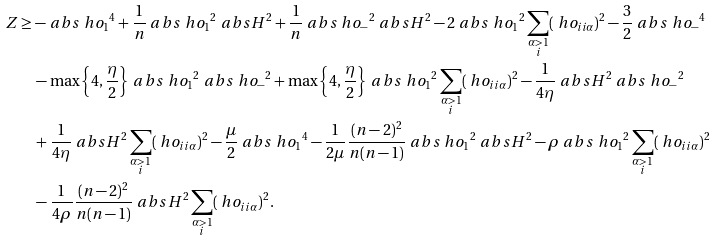Convert formula to latex. <formula><loc_0><loc_0><loc_500><loc_500>Z & \geq - \ a b s { \ h o _ { 1 } } ^ { 4 } + \frac { 1 } { n } \ a b s { \ h o _ { 1 } } ^ { 2 } \ a b s { H } ^ { 2 } + \frac { 1 } { n } \ a b s { \ h o _ { - } } ^ { 2 } \ a b s { H } ^ { 2 } - 2 \ a b s { \ h o _ { 1 } } ^ { 2 } \sum _ { \substack { \alpha > 1 \\ i } } ( \ h o _ { i i \alpha } ) ^ { 2 } - \frac { 3 } { 2 } \ a b s { \ h o _ { - } } ^ { 4 } \\ & \quad - \max \left \{ 4 , \frac { \eta } { 2 } \right \} \ a b s { \ h o _ { 1 } } ^ { 2 } \ a b s { \ h o _ { - } } ^ { 2 } + \max \left \{ 4 , \frac { \eta } { 2 } \right \} \ a b s { \ h o _ { 1 } } ^ { 2 } \sum _ { \substack { \alpha > 1 \\ i } } ( \ h o _ { i i \alpha } ) ^ { 2 } - \frac { 1 } { 4 \eta } \ a b s { H } ^ { 2 } \ a b s { \ h o _ { - } } ^ { 2 } \\ & \quad + \frac { 1 } { 4 \eta } \ a b s { H } ^ { 2 } \sum _ { \substack { \alpha > 1 \\ i } } ( \ h o _ { i i \alpha } ) ^ { 2 } - \frac { \mu } { 2 } \ a b s { \ h o _ { 1 } } ^ { 4 } - \frac { 1 } { 2 \mu } \frac { ( n - 2 ) ^ { 2 } } { n ( n - 1 ) } \ a b s { \ h o _ { 1 } } ^ { 2 } \ a b s { H } ^ { 2 } - \rho \ a b s { \ h o _ { 1 } } ^ { 2 } \sum _ { \substack { \alpha > 1 \\ i } } ( \ h o _ { i i \alpha } ) ^ { 2 } \\ & \quad - \frac { 1 } { 4 \rho } \frac { ( n - 2 ) ^ { 2 } } { n ( n - 1 ) } \ a b s { H } ^ { 2 } \sum _ { \substack { \alpha > 1 \\ i } } ( \ h o _ { i i \alpha } ) ^ { 2 } .</formula> 